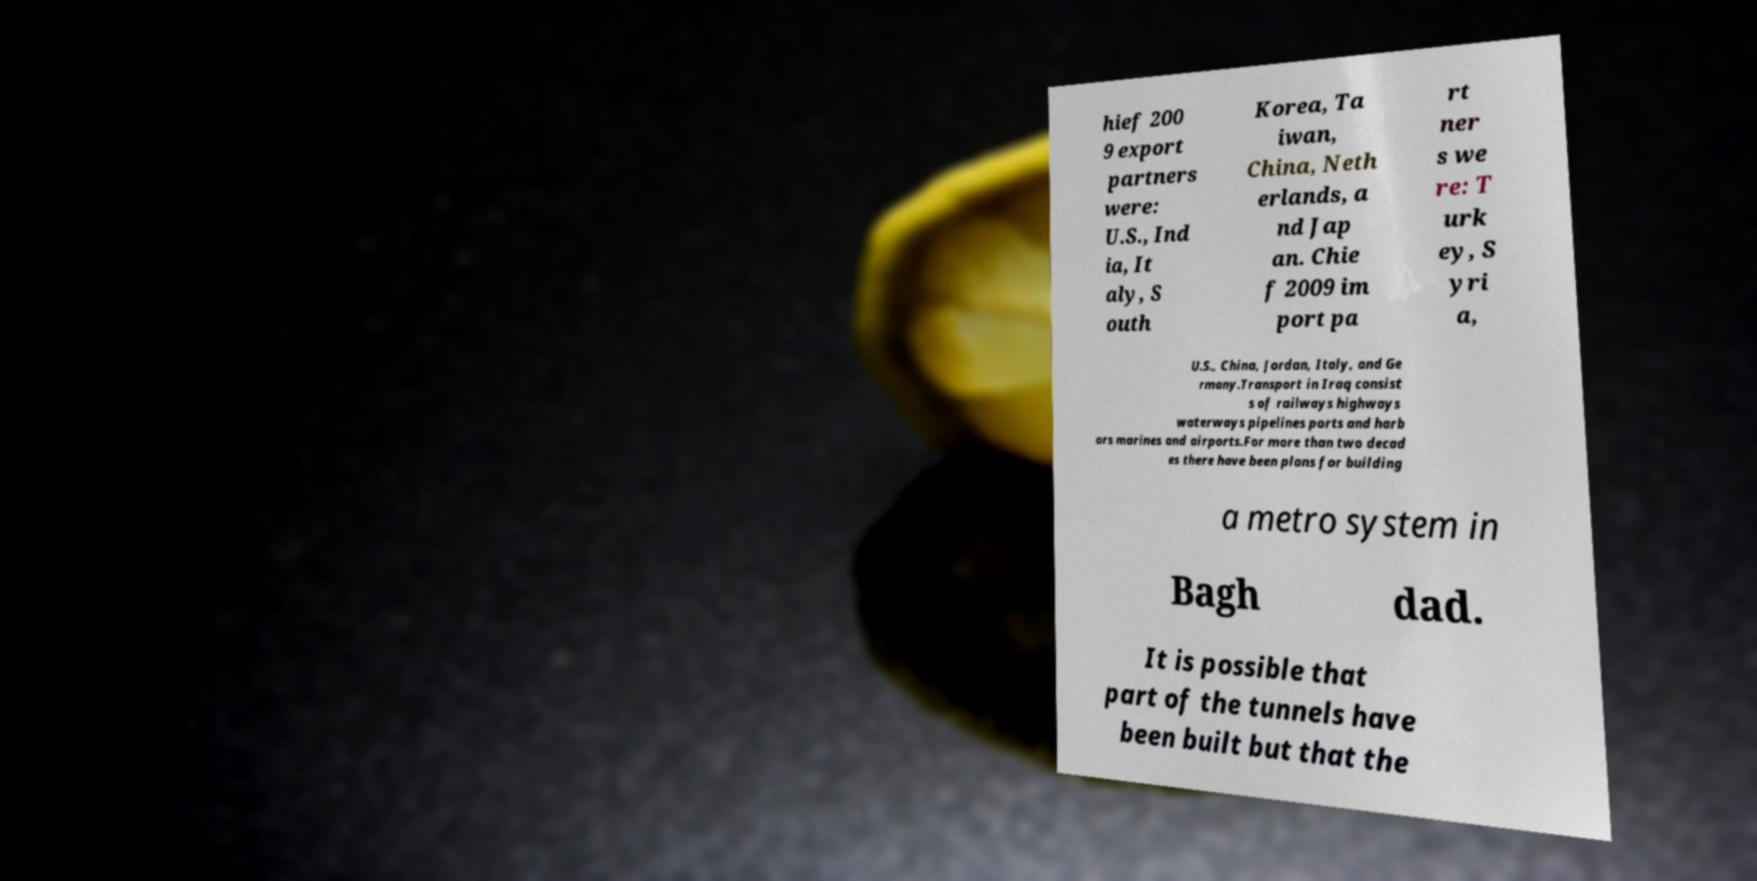Please identify and transcribe the text found in this image. hief 200 9 export partners were: U.S., Ind ia, It aly, S outh Korea, Ta iwan, China, Neth erlands, a nd Jap an. Chie f 2009 im port pa rt ner s we re: T urk ey, S yri a, U.S., China, Jordan, Italy, and Ge rmany.Transport in Iraq consist s of railways highways waterways pipelines ports and harb ors marines and airports.For more than two decad es there have been plans for building a metro system in Bagh dad. It is possible that part of the tunnels have been built but that the 